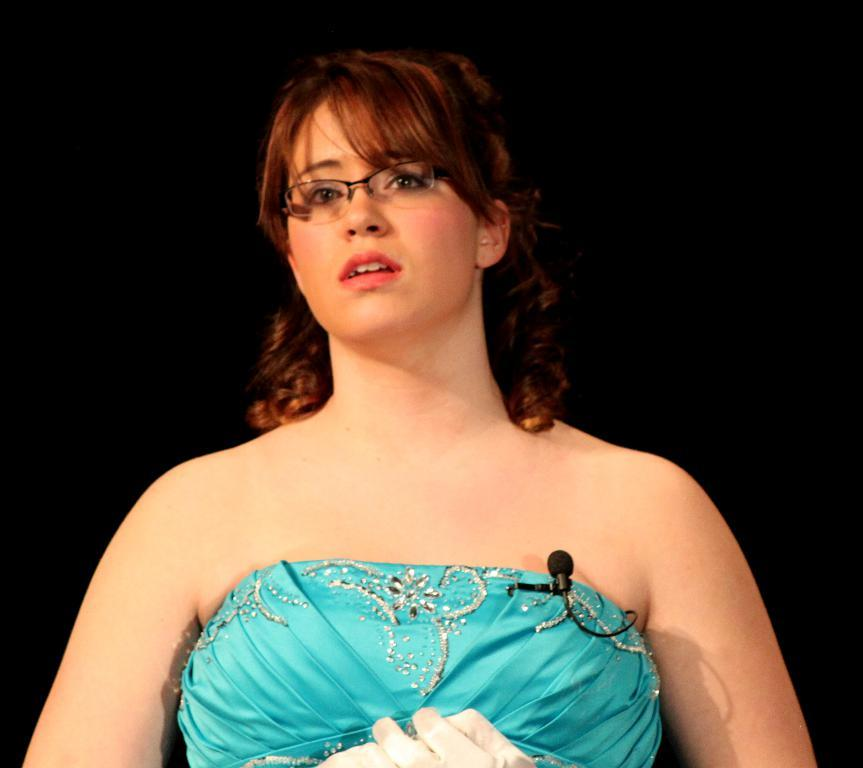Who is the main subject in the image? There is a woman in the image. What is the woman wearing on her face? The woman is wearing spectacles. What is the woman's posture in the image? The woman is standing. What is the woman holding near her mouth? The woman is wearing a microphone. What can be observed about the lighting in the image? The background of the image is dark. What type of government can be seen in the image? There is no reference to a government in the image; it features a woman wearing spectacles, standing, and wearing a microphone against a dark background. What border is visible in the image? There is no border present in the image. 